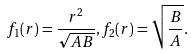<formula> <loc_0><loc_0><loc_500><loc_500>f _ { 1 } ( r ) = \frac { r ^ { 2 } } { \sqrt { A B } } , f _ { 2 } ( r ) = \sqrt { \frac { B } { A } } .</formula> 